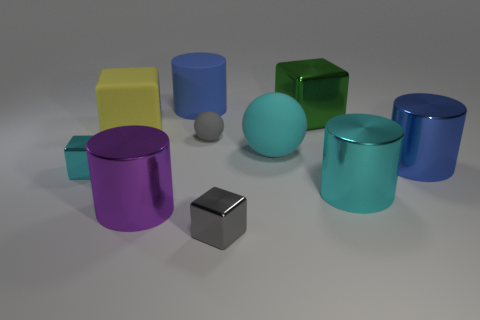Subtract all gray cubes. How many cubes are left? 3 Subtract all cyan spheres. How many blue cylinders are left? 2 Subtract all purple cylinders. How many cylinders are left? 3 Subtract 2 blocks. How many blocks are left? 2 Subtract all cubes. How many objects are left? 6 Subtract all cyan cubes. Subtract all red balls. How many cubes are left? 3 Add 1 big purple cylinders. How many big purple cylinders are left? 2 Add 5 balls. How many balls exist? 7 Subtract 0 purple cubes. How many objects are left? 10 Subtract all cyan cylinders. Subtract all small cyan metallic objects. How many objects are left? 8 